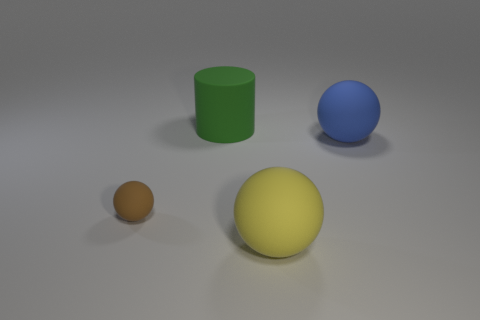Is there anything else that has the same size as the green thing?
Make the answer very short. Yes. There is a object that is on the left side of the large blue rubber thing and behind the tiny rubber ball; what shape is it?
Offer a terse response. Cylinder. What is the color of the other big ball that is made of the same material as the blue ball?
Offer a terse response. Yellow. Are there an equal number of large spheres that are behind the large blue matte object and blue matte balls?
Your response must be concise. No. The yellow rubber thing that is the same size as the cylinder is what shape?
Offer a very short reply. Sphere. How many other objects are there of the same shape as the green rubber thing?
Provide a succinct answer. 0. There is a blue matte sphere; is its size the same as the matte ball that is in front of the tiny ball?
Your answer should be very brief. Yes. How many objects are either rubber things that are on the right side of the large cylinder or large cyan objects?
Your answer should be compact. 2. There is a thing that is behind the blue rubber object; what shape is it?
Offer a terse response. Cylinder. Are there the same number of yellow matte spheres on the left side of the large green cylinder and small brown balls that are right of the yellow matte object?
Your response must be concise. Yes. 